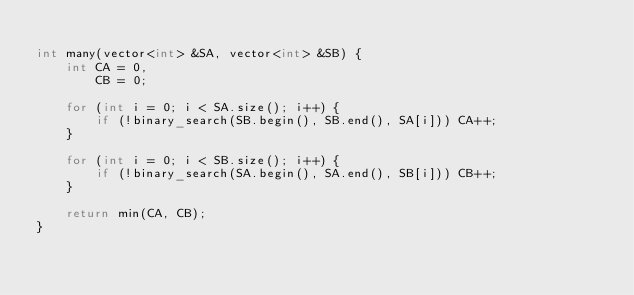Convert code to text. <code><loc_0><loc_0><loc_500><loc_500><_C++_>
int many(vector<int> &SA, vector<int> &SB) {
    int CA = 0,
        CB = 0;

    for (int i = 0; i < SA.size(); i++) {
        if (!binary_search(SB.begin(), SB.end(), SA[i])) CA++;
    }

    for (int i = 0; i < SB.size(); i++) {
        if (!binary_search(SA.begin(), SA.end(), SB[i])) CB++;
    }

    return min(CA, CB);
}
</code> 